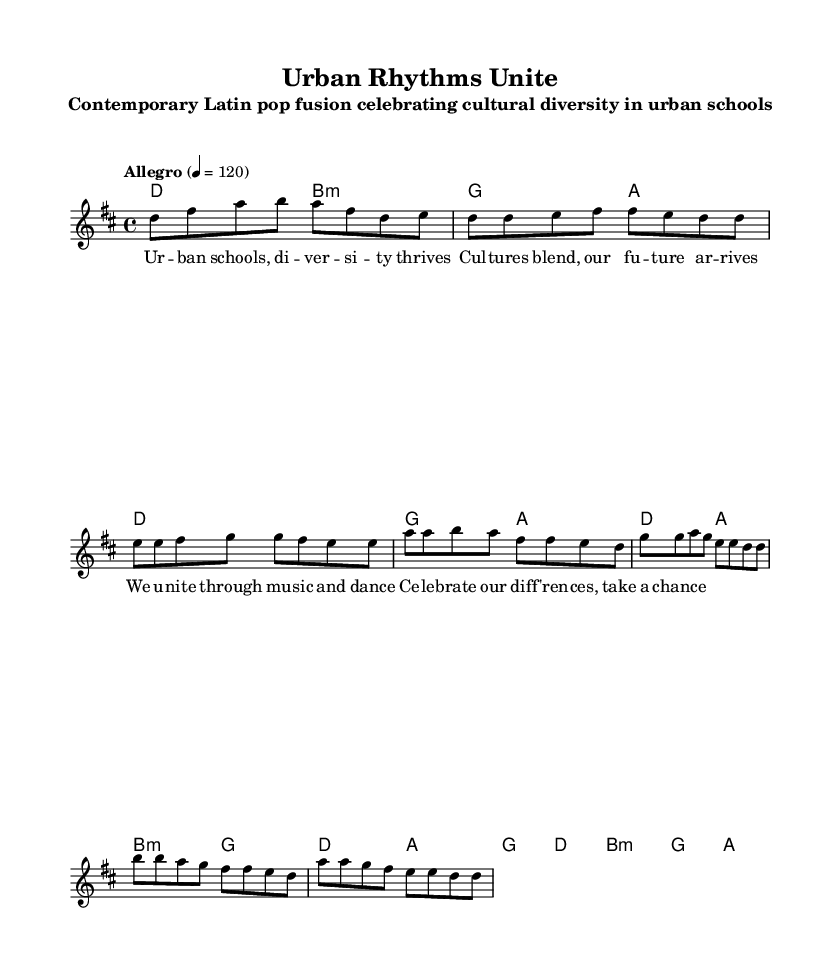What is the key signature of this music? The key signature is D major, which has two sharps: F# and C#.
Answer: D major What is the time signature of this music? The time signature is 4/4, indicating four beats per measure.
Answer: 4/4 What is the tempo marking of this music? The tempo marking is "Allegro," which indicates a fast and lively tempo.
Answer: Allegro What are the first two notes of the chorus? The first two notes of the chorus are A and A. This can be found in the melody section under the chorus indication.
Answer: A, A What chords are used in the bridge section? The bridge section uses the chords B minor and G, which are indicated in the harmonies part of the music during that section.
Answer: B minor, G How does the melody of the verse compare to the melody of the chorus? The verse melody starts with D and progresses with a series of notes upward, while the chorus melody begins with A and emphasizes a repeated rhythm and different notes. The transition to chorus marks a change in musical direction, emphasizing unity and celebration.
Answer: Different starting notes and rhythmic emphasis What theme do the lyrics of the song convey? The lyrics emphasize cultural diversity and the celebration of differences, suggesting a theme of unity through music and dance within urban schools.
Answer: Cultural diversity and unity 